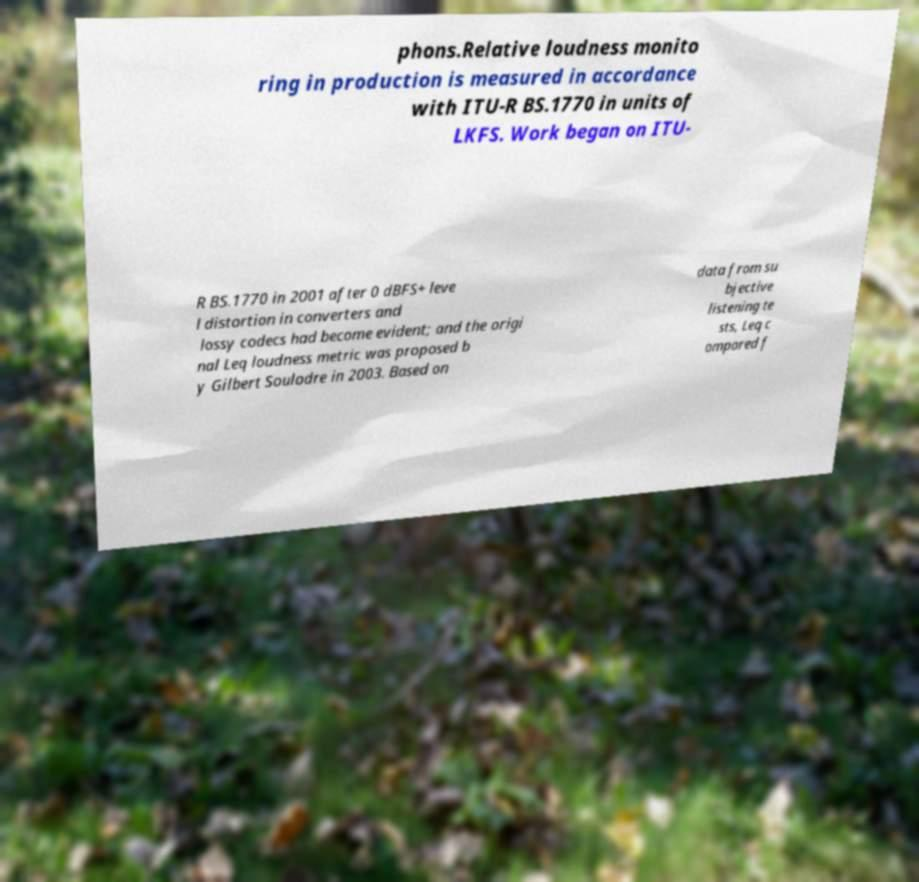For documentation purposes, I need the text within this image transcribed. Could you provide that? phons.Relative loudness monito ring in production is measured in accordance with ITU-R BS.1770 in units of LKFS. Work began on ITU- R BS.1770 in 2001 after 0 dBFS+ leve l distortion in converters and lossy codecs had become evident; and the origi nal Leq loudness metric was proposed b y Gilbert Soulodre in 2003. Based on data from su bjective listening te sts, Leq c ompared f 